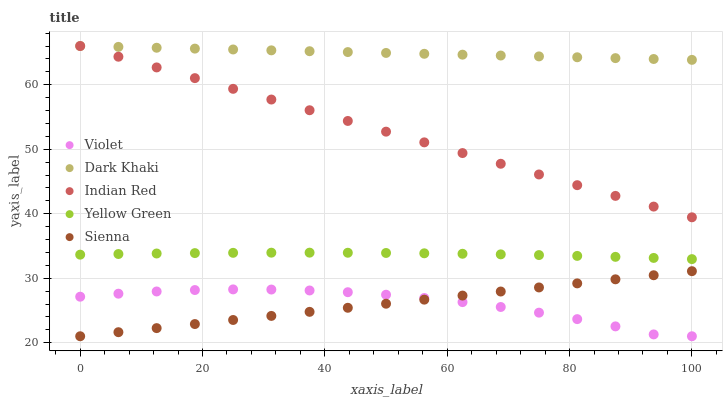Does Sienna have the minimum area under the curve?
Answer yes or no. Yes. Does Dark Khaki have the maximum area under the curve?
Answer yes or no. Yes. Does Yellow Green have the minimum area under the curve?
Answer yes or no. No. Does Yellow Green have the maximum area under the curve?
Answer yes or no. No. Is Sienna the smoothest?
Answer yes or no. Yes. Is Violet the roughest?
Answer yes or no. Yes. Is Yellow Green the smoothest?
Answer yes or no. No. Is Yellow Green the roughest?
Answer yes or no. No. Does Sienna have the lowest value?
Answer yes or no. Yes. Does Yellow Green have the lowest value?
Answer yes or no. No. Does Indian Red have the highest value?
Answer yes or no. Yes. Does Sienna have the highest value?
Answer yes or no. No. Is Violet less than Yellow Green?
Answer yes or no. Yes. Is Yellow Green greater than Sienna?
Answer yes or no. Yes. Does Indian Red intersect Dark Khaki?
Answer yes or no. Yes. Is Indian Red less than Dark Khaki?
Answer yes or no. No. Is Indian Red greater than Dark Khaki?
Answer yes or no. No. Does Violet intersect Yellow Green?
Answer yes or no. No. 